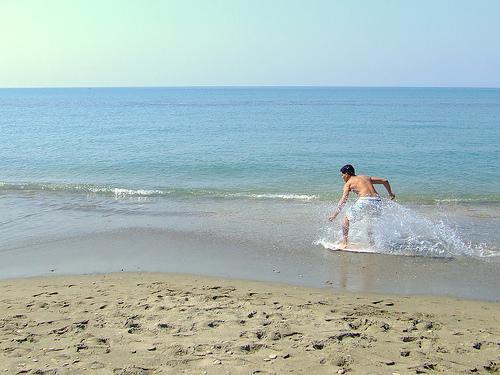How many people are in the picture?
Give a very brief answer. 1. How many waves are there?
Give a very brief answer. 1. 